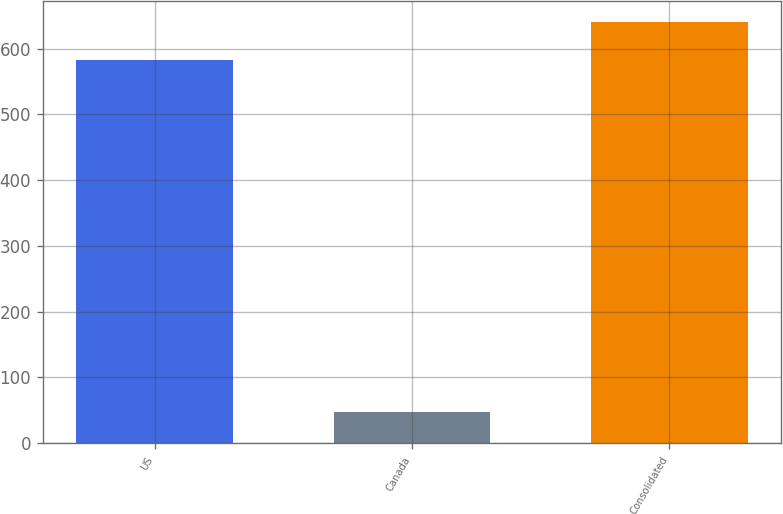<chart> <loc_0><loc_0><loc_500><loc_500><bar_chart><fcel>US<fcel>Canada<fcel>Consolidated<nl><fcel>582.3<fcel>47.8<fcel>640.53<nl></chart> 